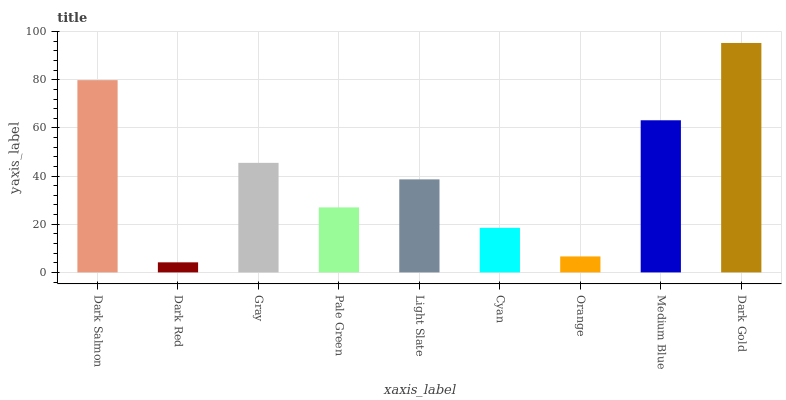Is Gray the minimum?
Answer yes or no. No. Is Gray the maximum?
Answer yes or no. No. Is Gray greater than Dark Red?
Answer yes or no. Yes. Is Dark Red less than Gray?
Answer yes or no. Yes. Is Dark Red greater than Gray?
Answer yes or no. No. Is Gray less than Dark Red?
Answer yes or no. No. Is Light Slate the high median?
Answer yes or no. Yes. Is Light Slate the low median?
Answer yes or no. Yes. Is Orange the high median?
Answer yes or no. No. Is Orange the low median?
Answer yes or no. No. 